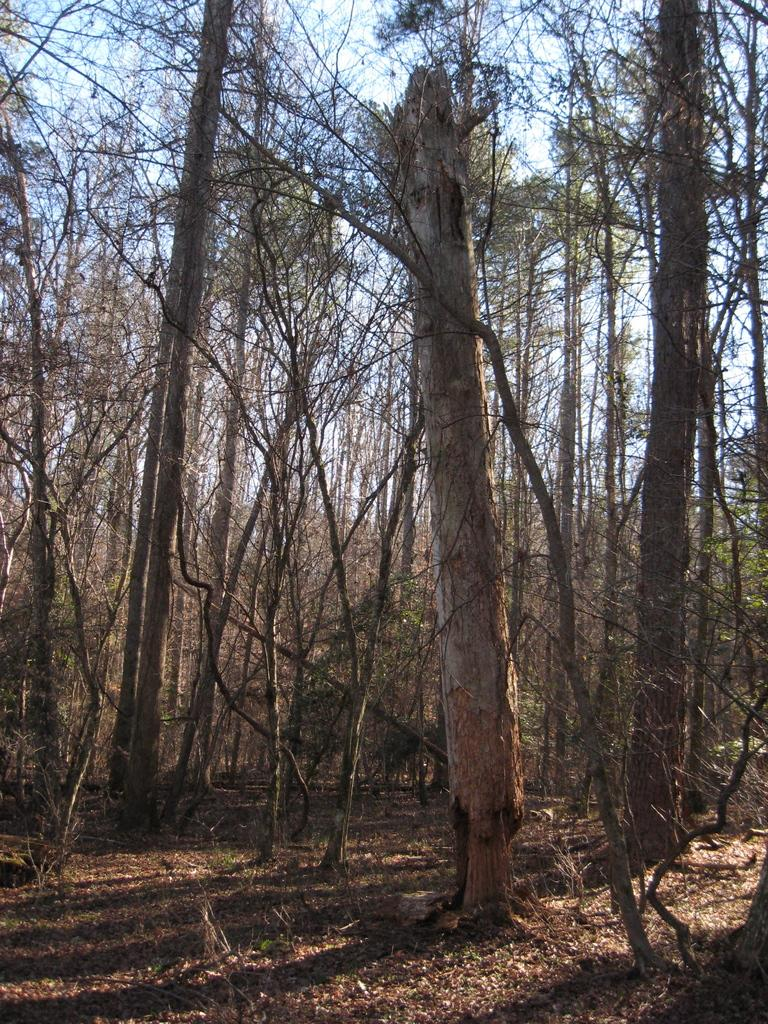What type of environment is depicted in the image? The image appears to depict a forest. What can be seen on the ground in the image? There are many trees on the ground in the image. What is visible at the top of the image? The sky is visible at the top of the image. What type of boats can be seen sailing in the forest in the image? There are no boats present in the image, as it depicts a forest environment. 